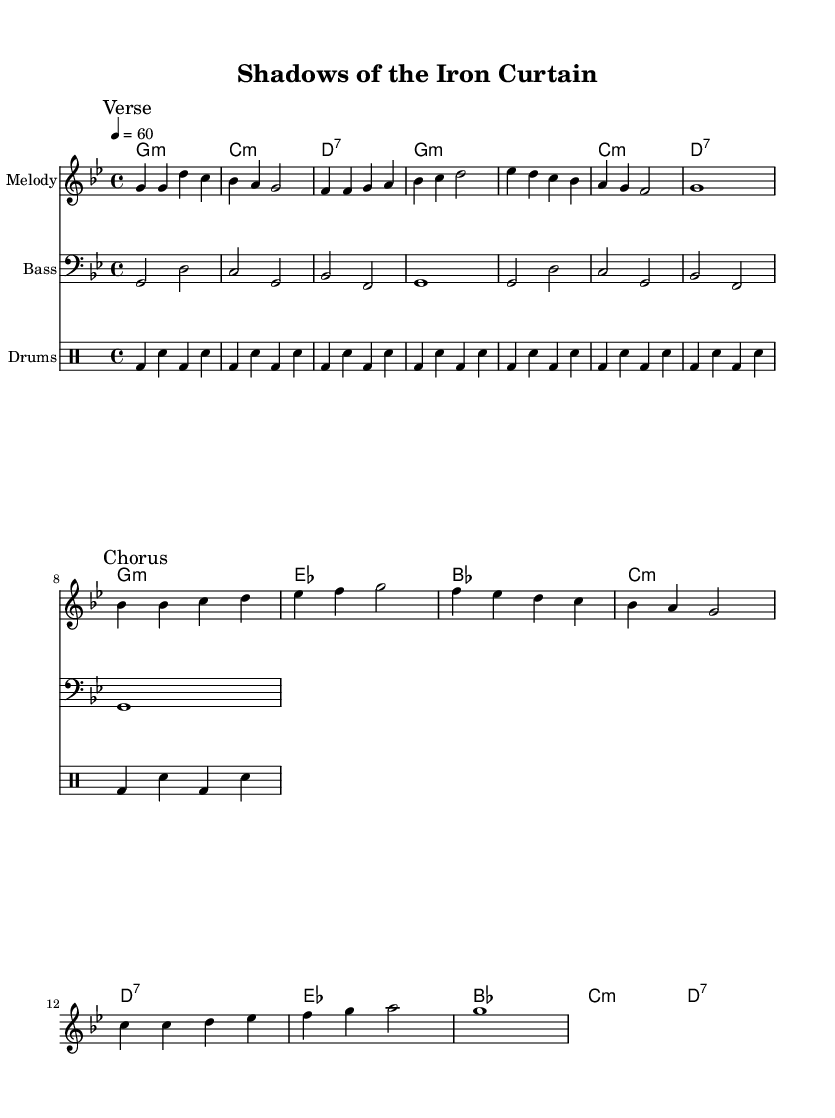What is the key signature of this music? The key signature shown in the global settings at the beginning of the music sheet is G minor, which has two flats (B♭, E♭).
Answer: G minor What is the time signature of this music? The time signature indicated in the global settings is 4/4, which means there are four beats per measure and the quarter note gets one beat.
Answer: 4/4 What is the tempo marking for this piece? The tempo marking in the global settings states that the tempo is set to 60 beats per minute, which denotes a moderate pace.
Answer: 60 How many measures are in the verse section? Counting the measures in the melody for the verse section, there are a total of 8 measures before the break.
Answer: 8 Which chord appears most frequently in the chord progression? Analyzing the chord progression, G minor appears most frequently and is a staple of this musical piece.
Answer: G minor What lyrical theme is presented in the chorus? The chorus lyrics reflect a theme of division and longing for unity amidst the tensions of the Cold War era, highlighting emotional distress.
Answer: Division and longing for unity What type of drum pattern is used in this piece? The drum part consists of a repeated kick-snare pattern, which is common in rhythm and blues music, providing a steady backbeat.
Answer: Kick-snare pattern 